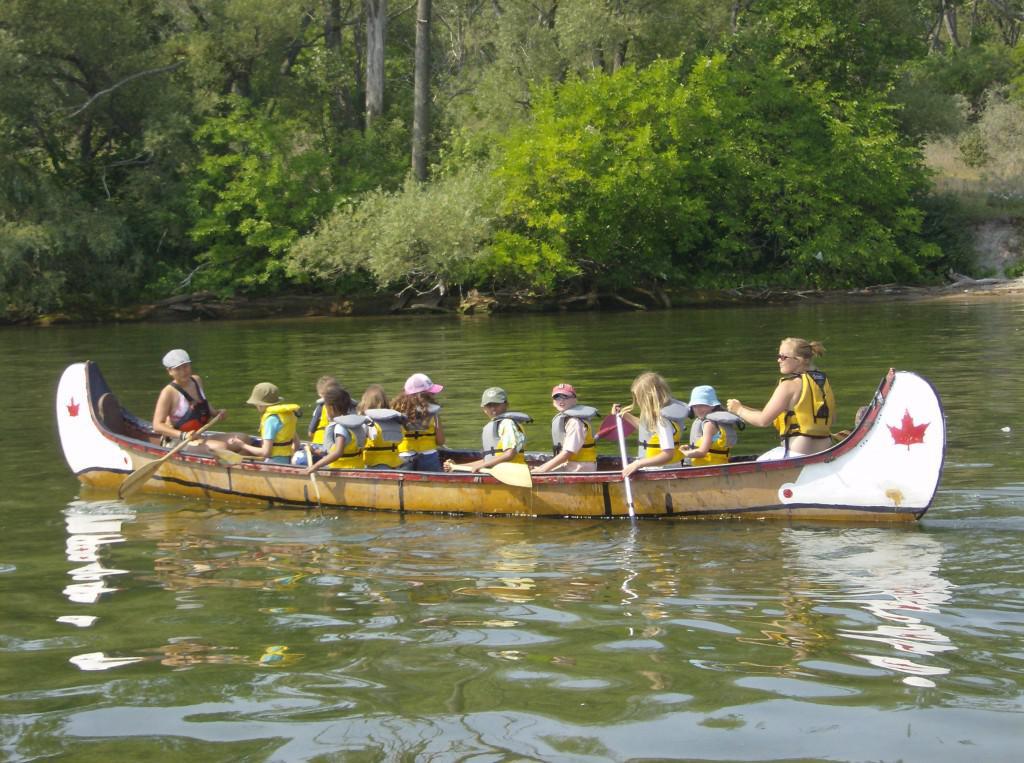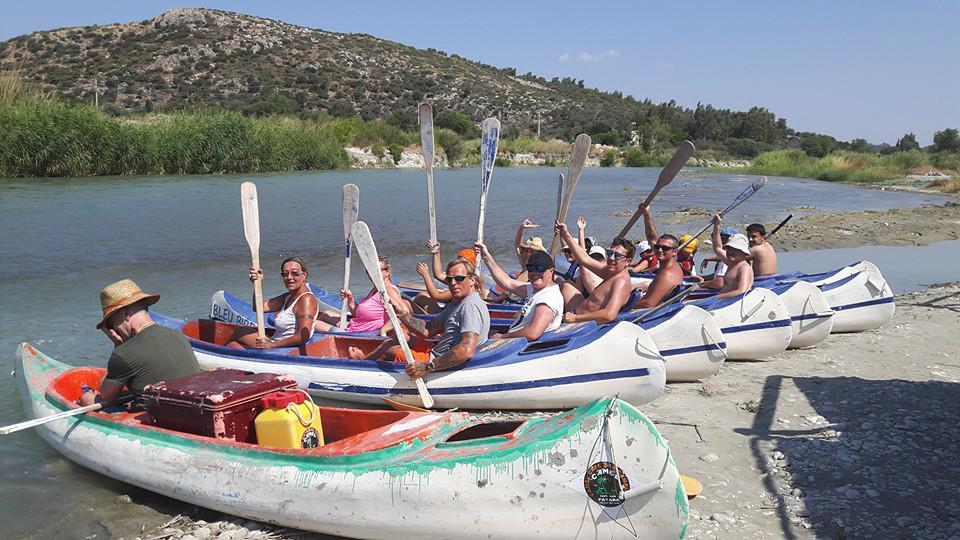The first image is the image on the left, the second image is the image on the right. Examine the images to the left and right. Is the description "There is exactly one boat in the left image." accurate? Answer yes or no. Yes. The first image is the image on the left, the second image is the image on the right. For the images displayed, is the sentence "Each image includes at least one person in a canoe on water, with the boat aimed forward." factually correct? Answer yes or no. No. 